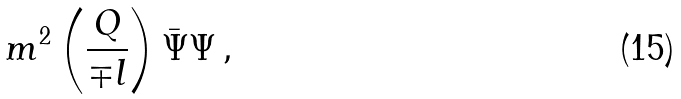Convert formula to latex. <formula><loc_0><loc_0><loc_500><loc_500>m ^ { 2 } \left ( \frac { Q } { \mp l } \right ) \bar { \Psi } \Psi \, ,</formula> 